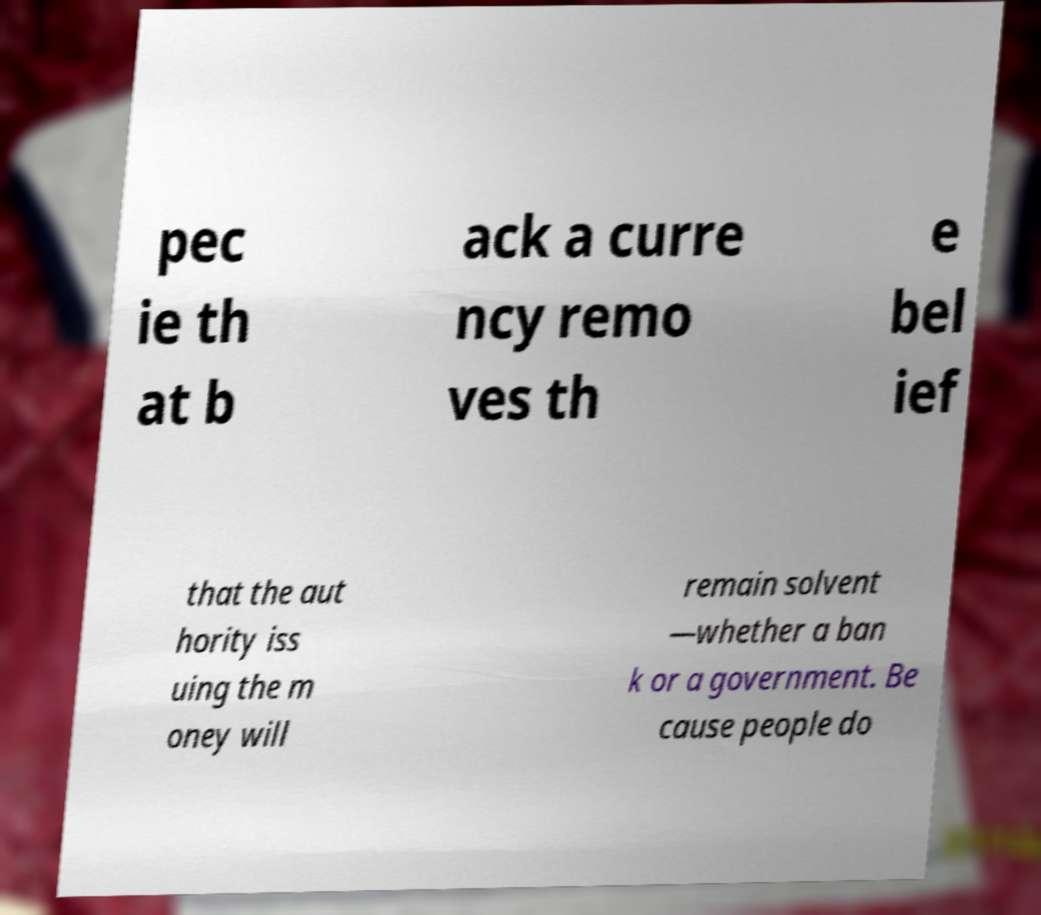Can you accurately transcribe the text from the provided image for me? pec ie th at b ack a curre ncy remo ves th e bel ief that the aut hority iss uing the m oney will remain solvent —whether a ban k or a government. Be cause people do 